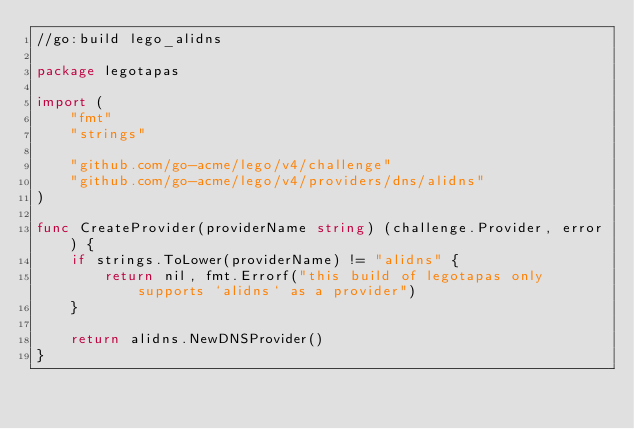<code> <loc_0><loc_0><loc_500><loc_500><_Go_>//go:build lego_alidns

package legotapas

import (
    "fmt"
    "strings"

    "github.com/go-acme/lego/v4/challenge"
    "github.com/go-acme/lego/v4/providers/dns/alidns"
)

func CreateProvider(providerName string) (challenge.Provider, error) {
    if strings.ToLower(providerName) != "alidns" {
        return nil, fmt.Errorf("this build of legotapas only supports `alidns` as a provider")
    }

    return alidns.NewDNSProvider()
}
</code> 